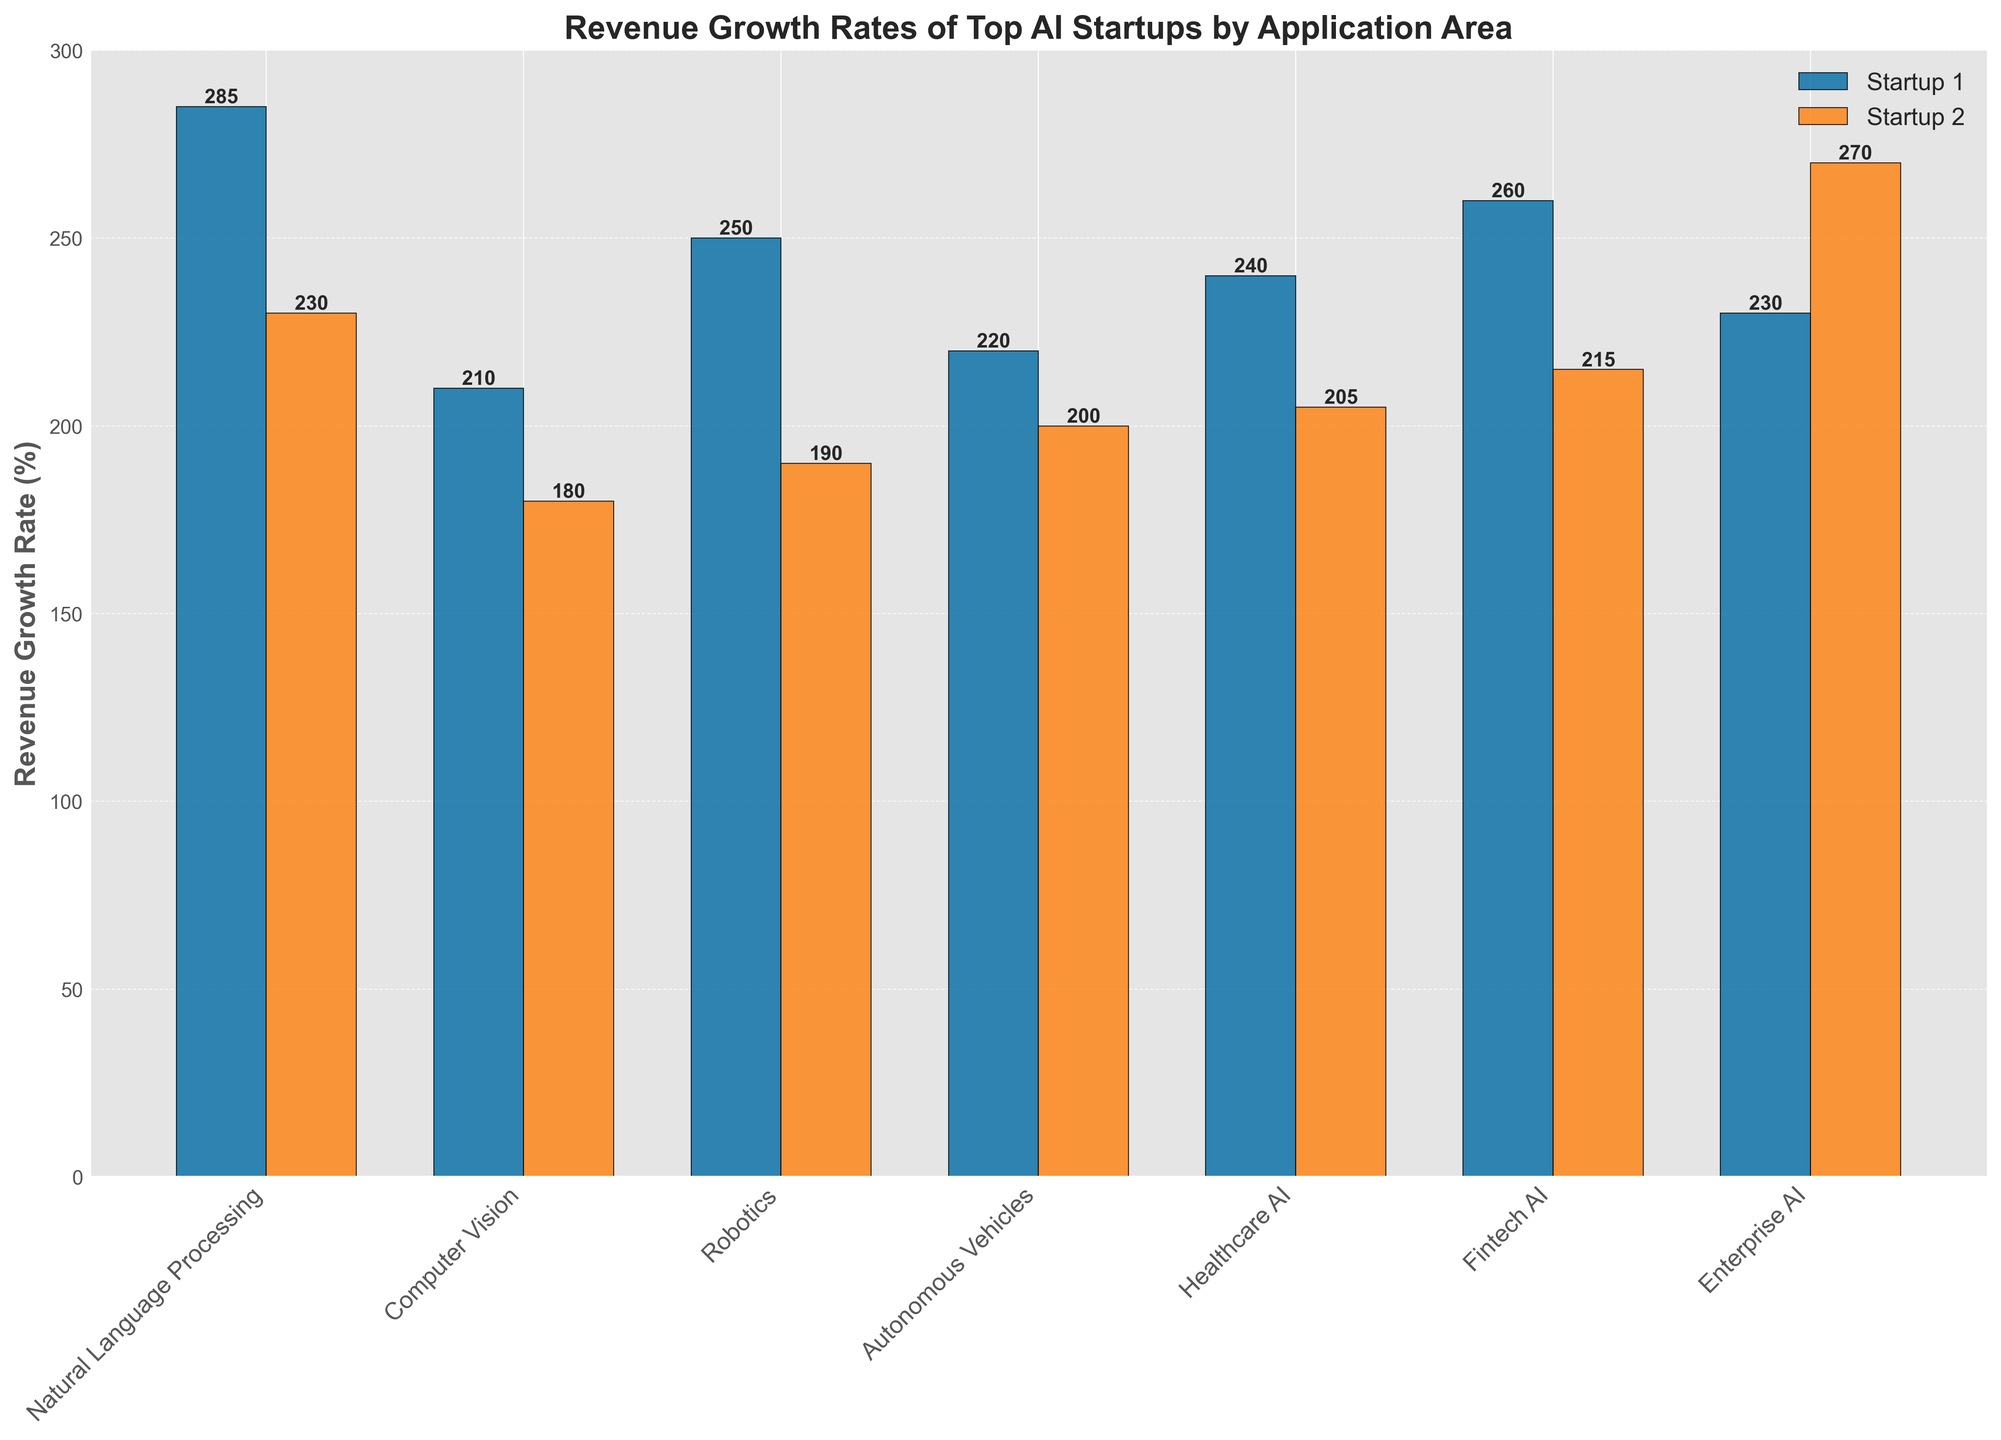Which application area has the highest revenue growth rate for any startup? The bar corresponding to OpenAI, a Natural Language Processing startup, is the tallest, indicating the highest revenue growth rate.
Answer: Natural Language Processing What is the difference in revenue growth rates between the top startups in Natural Language Processing and Computer Vision? The highest revenue growth rate in Natural Language Processing is 285% (OpenAI), and the highest in Computer Vision is 210% (Scale AI). The difference is 285% - 210%.
Answer: 75% How do the top startup's revenue growth rates in Robotics and Autonomous Vehicles compare? The highest revenue growth rate in Robotics is 250% (Anduril), and in Autonomous Vehicles, it is 220% (Aurora). 250% is greater than 220%.
Answer: Robotics is higher Which application area shows more evenly distributed revenue growth rates among the top startups, Natural Language Processing or Healthcare AI? Examine the height differences among the bars for each startup within the areas. Natural Language Processing (285%, 230%, 195%) has a wider range of values compared to Healthcare AI (240%, 205%, 175%).
Answer: Healthcare AI What’s the average revenue growth rate for startups in the Fintech AI application area? Fintech AI startups have growth rates of 260%, 215%, and 185%. Average = (260 + 215 + 185) / 3
Answer: 220% Which startup in Healthcare AI has a higher revenue growth rate than Waymo in Autonomous Vehicles? Waymo in Autonomous Vehicles has a growth rate of 200%. In Healthcare AI, both Tempus (240%) and Insitro (205%) have higher growth rates than Waymo.
Answer: Tempus, Insitro Which Enterprise AI startup has a higher revenue growth rate? Compare the bars for C3.ai and DataBricks in Enterprise AI. DataBricks has a taller bar.
Answer: DataBricks What’s the total revenue growth rate for the top startups in Computer Vision? Sum the growth rates for top Computer Vision startups: Scale AI (210%), Clarifai (180%), and Dataminr (165%). Total = 210% + 180% + 165%
Answer: 555% What is twice the revenue growth rate of the lowest startup in Natural Language Processing? The lowest revenue growth rate in Natural Language Processing is 195% (Cohere). Twice this value is 195% x 2.
Answer: 390% 